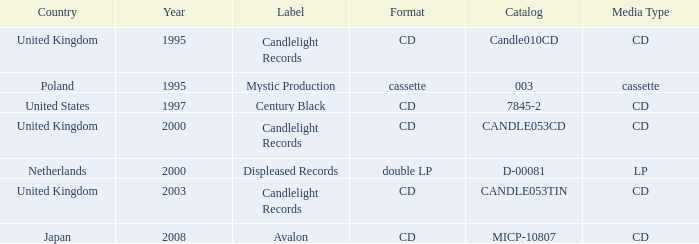What is Candlelight Records format? CD, CD, CD. 